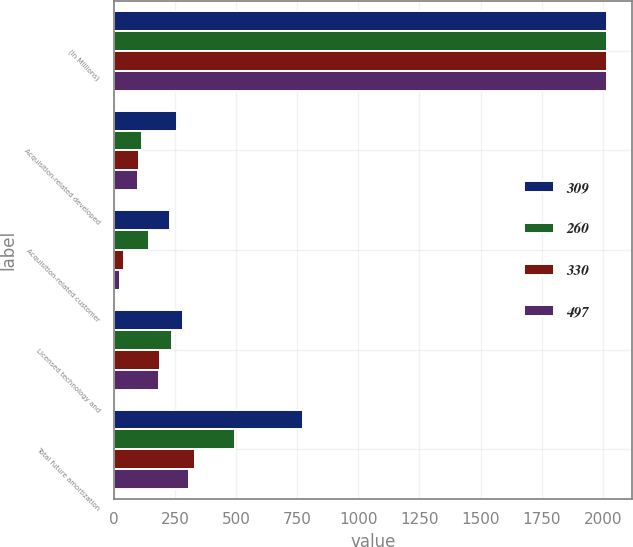<chart> <loc_0><loc_0><loc_500><loc_500><stacked_bar_chart><ecel><fcel>(In Millions)<fcel>Acquisition-related developed<fcel>Acquisition-related customer<fcel>Licensed technology and<fcel>Total future amortization<nl><fcel>309<fcel>2016<fcel>260<fcel>229<fcel>282<fcel>774<nl><fcel>260<fcel>2017<fcel>115<fcel>143<fcel>239<fcel>497<nl><fcel>330<fcel>2018<fcel>101<fcel>42<fcel>187<fcel>330<nl><fcel>497<fcel>2019<fcel>98<fcel>25<fcel>186<fcel>309<nl></chart> 